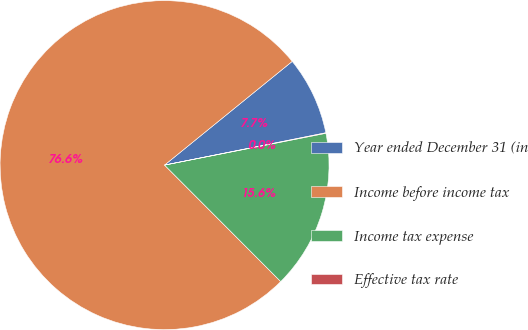Convert chart. <chart><loc_0><loc_0><loc_500><loc_500><pie_chart><fcel>Year ended December 31 (in<fcel>Income before income tax<fcel>Income tax expense<fcel>Effective tax rate<nl><fcel>7.71%<fcel>76.62%<fcel>15.62%<fcel>0.05%<nl></chart> 